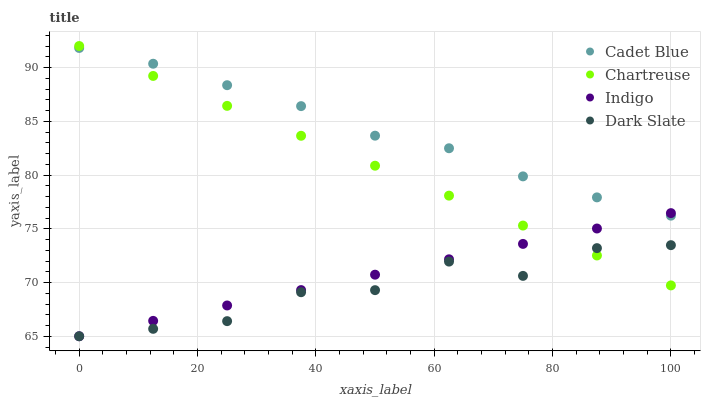Does Dark Slate have the minimum area under the curve?
Answer yes or no. Yes. Does Cadet Blue have the maximum area under the curve?
Answer yes or no. Yes. Does Chartreuse have the minimum area under the curve?
Answer yes or no. No. Does Chartreuse have the maximum area under the curve?
Answer yes or no. No. Is Chartreuse the smoothest?
Answer yes or no. Yes. Is Dark Slate the roughest?
Answer yes or no. Yes. Is Cadet Blue the smoothest?
Answer yes or no. No. Is Cadet Blue the roughest?
Answer yes or no. No. Does Dark Slate have the lowest value?
Answer yes or no. Yes. Does Chartreuse have the lowest value?
Answer yes or no. No. Does Chartreuse have the highest value?
Answer yes or no. Yes. Does Cadet Blue have the highest value?
Answer yes or no. No. Is Dark Slate less than Cadet Blue?
Answer yes or no. Yes. Is Cadet Blue greater than Dark Slate?
Answer yes or no. Yes. Does Indigo intersect Cadet Blue?
Answer yes or no. Yes. Is Indigo less than Cadet Blue?
Answer yes or no. No. Is Indigo greater than Cadet Blue?
Answer yes or no. No. Does Dark Slate intersect Cadet Blue?
Answer yes or no. No. 